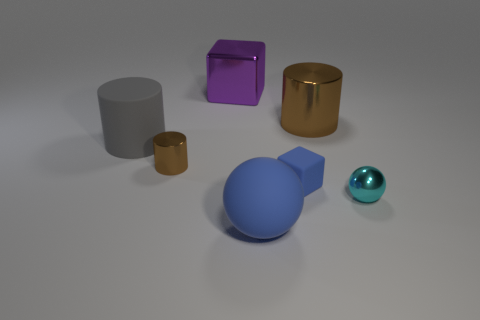Is there a matte thing that has the same size as the blue sphere?
Your answer should be very brief. Yes. What material is the cylinder that is the same size as the blue matte block?
Ensure brevity in your answer.  Metal. What is the shape of the rubber thing that is both on the left side of the blue rubber cube and behind the big blue matte ball?
Provide a succinct answer. Cylinder. The small metallic object behind the blue cube is what color?
Your response must be concise. Brown. What size is the shiny object that is both to the left of the tiny cyan metallic thing and to the right of the metallic cube?
Provide a short and direct response. Large. Is the material of the big purple object the same as the ball that is on the right side of the big brown metallic cylinder?
Your answer should be compact. Yes. What number of blue things are the same shape as the big brown metal thing?
Keep it short and to the point. 0. There is a tiny cube that is the same color as the big sphere; what is it made of?
Make the answer very short. Rubber. What number of small brown objects are there?
Offer a terse response. 1. There is a big gray matte thing; is its shape the same as the brown object that is on the left side of the large purple thing?
Make the answer very short. Yes. 